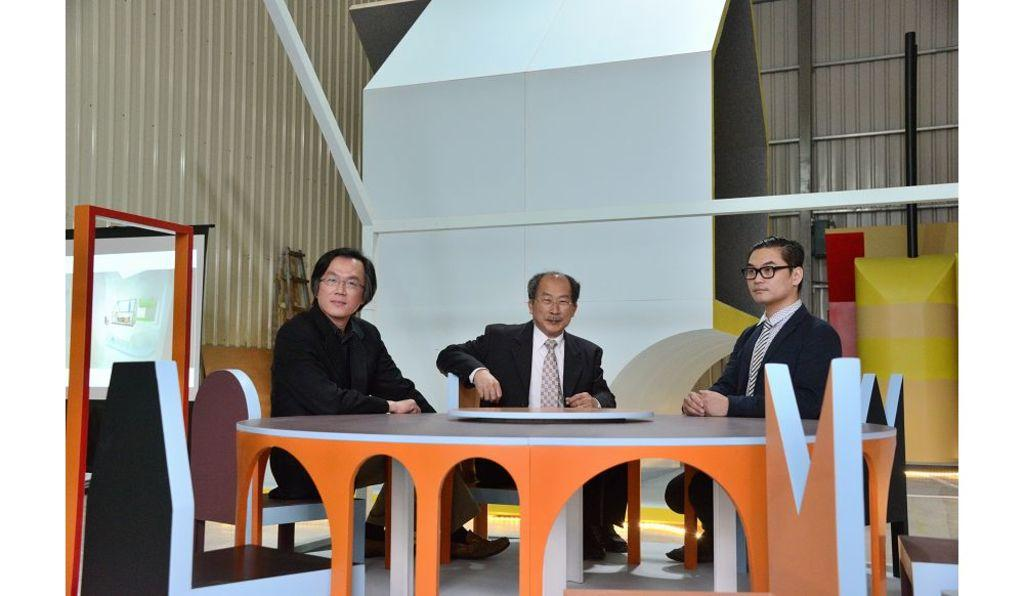What are the people in the image doing? The people in the foreground of the image are sitting. What is in front of the people? The people are sitting in front of a table. What can be seen in the background of the image? There is a door and other objects in the background of the image. Can you see a sock on the table in the image? There is no sock visible on the table in the image. 